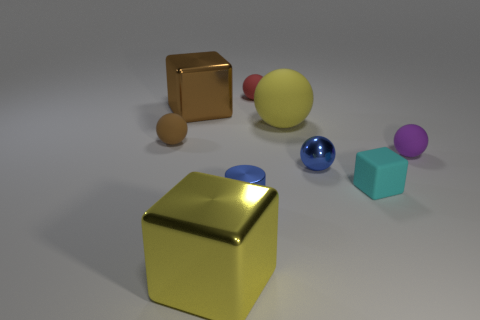There is a large block in front of the big cube behind the tiny purple ball; what color is it?
Your response must be concise. Yellow. How many other things are the same material as the tiny blue ball?
Your answer should be compact. 3. Are there an equal number of yellow metal cubes that are behind the small brown thing and tiny purple matte blocks?
Your response must be concise. Yes. What material is the large cube that is to the left of the shiny block that is in front of the sphere on the left side of the small blue metallic cylinder?
Offer a very short reply. Metal. There is a big shiny object that is in front of the small brown matte ball; what is its color?
Your answer should be compact. Yellow. There is a object on the left side of the big metallic block behind the small brown matte sphere; what size is it?
Offer a terse response. Small. Are there the same number of large yellow matte objects in front of the cyan rubber object and tiny metal spheres that are behind the tiny shiny sphere?
Offer a terse response. Yes. There is a sphere that is made of the same material as the brown cube; what color is it?
Make the answer very short. Blue. Are the tiny brown sphere and the tiny cube in front of the big brown object made of the same material?
Give a very brief answer. Yes. What color is the object that is in front of the small red sphere and behind the big yellow sphere?
Keep it short and to the point. Brown. 